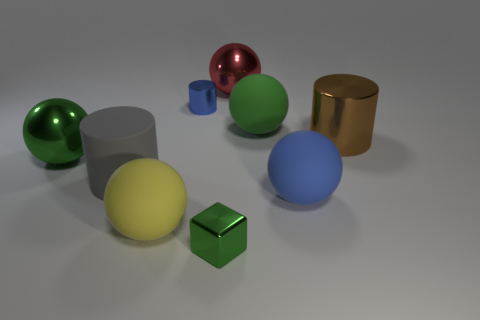Subtract all big blue spheres. How many spheres are left? 4 Subtract all red spheres. How many spheres are left? 4 Subtract all brown balls. Subtract all yellow cylinders. How many balls are left? 5 Subtract all cylinders. How many objects are left? 6 Subtract 1 blue cylinders. How many objects are left? 8 Subtract all large red shiny objects. Subtract all green matte balls. How many objects are left? 7 Add 6 yellow spheres. How many yellow spheres are left? 7 Add 4 yellow spheres. How many yellow spheres exist? 5 